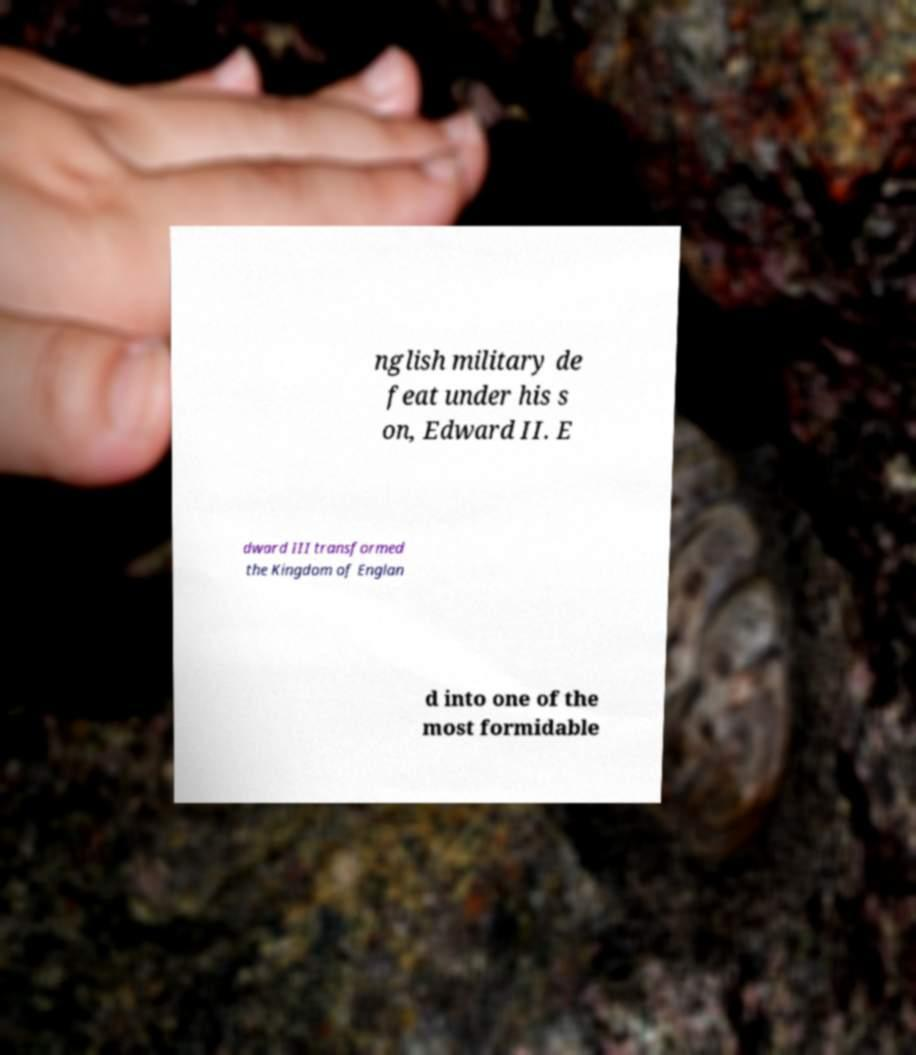For documentation purposes, I need the text within this image transcribed. Could you provide that? nglish military de feat under his s on, Edward II. E dward III transformed the Kingdom of Englan d into one of the most formidable 